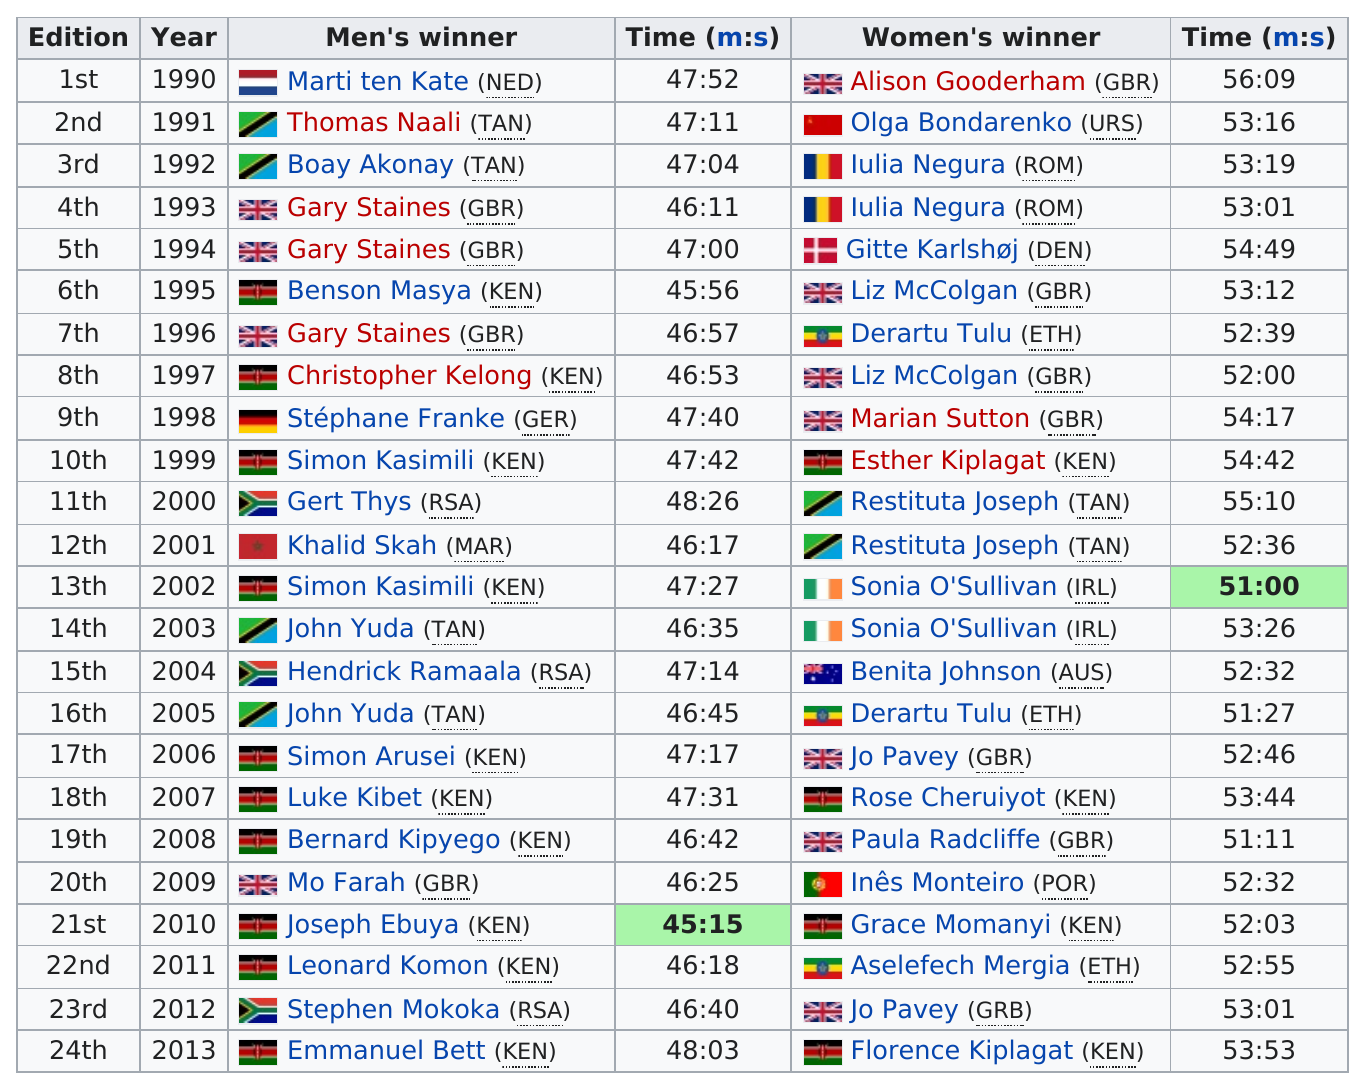Mention a couple of crucial points in this snapshot. The male winner listed before Gert Thys is Simon Kasimili. Of the men who won, how many had times that were at least 46 minutes or under? There were 12 men who finished the race with a time under 46:58. During the period of 1990 to 2013, there were 13 occasions when Britain did not win the men's or women's Bupa Great South Run. The first women's winner is named Alison Gooderham. 